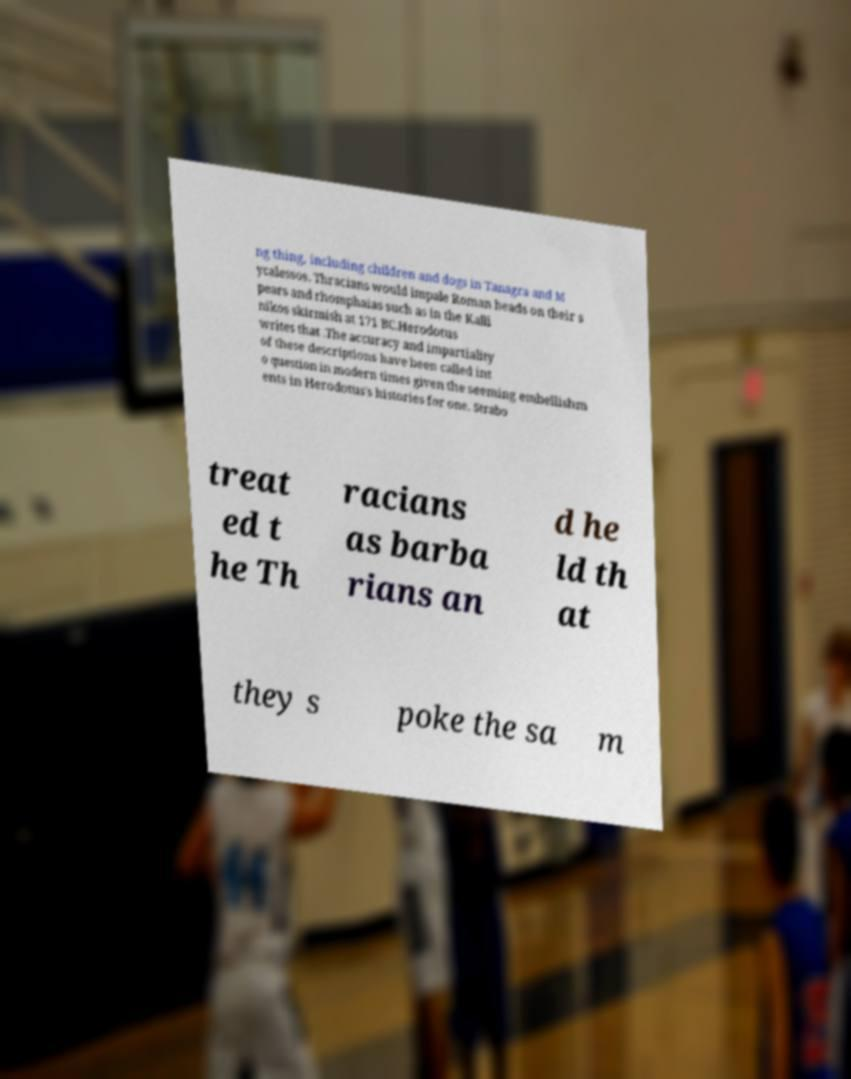Could you extract and type out the text from this image? ng thing, including children and dogs in Tanagra and M ycalessos. Thracians would impale Roman heads on their s pears and rhomphaias such as in the Kalli nikos skirmish at 171 BC.Herodotus writes that .The accuracy and impartiality of these descriptions have been called int o question in modern times given the seeming embellishm ents in Herodotus's histories for one. Strabo treat ed t he Th racians as barba rians an d he ld th at they s poke the sa m 